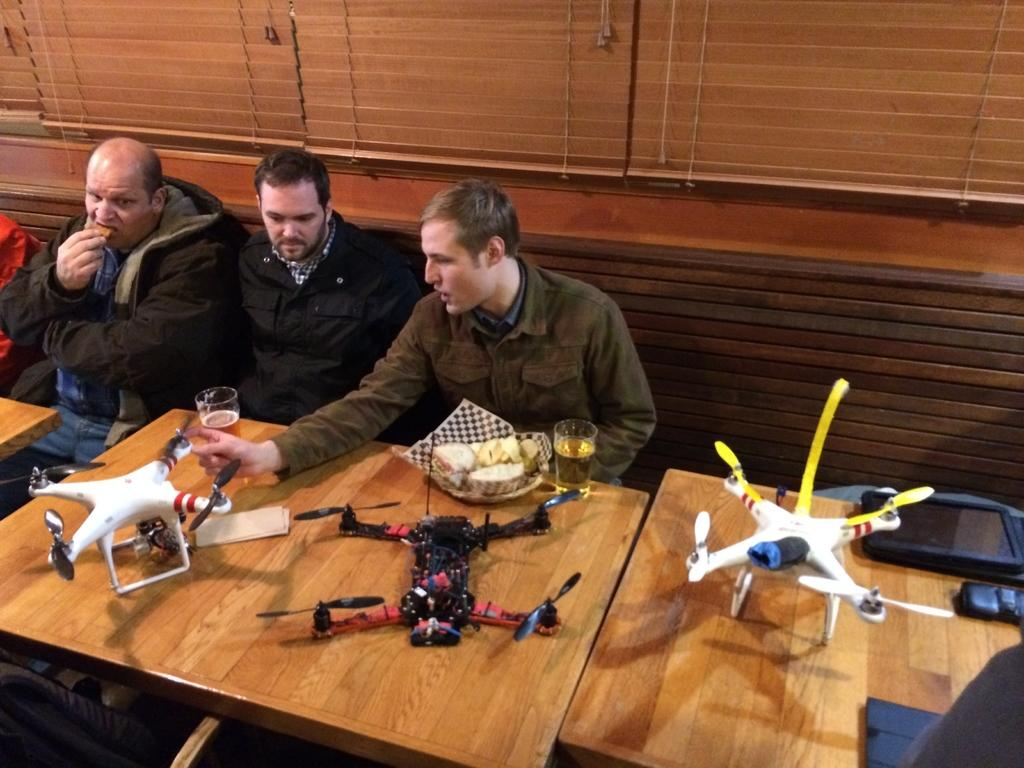What type of furniture can be seen in the image? There are tables in the image. What objects are on the tables? Drones and glasses are on the tables. Are there any other items on the tables? Yes, there are other items on the tables. What are the men in the image doing? There are three men sitting on a bench in the image. What can be seen in the background of the image? There are curtains of windows in the background of the image. Is there a parcel being delivered to the men on the bench in the image? There is no mention of a parcel or delivery in the image. Is this a birthday celebration, as indicated by the presence of the drones and glasses? There is no indication in the image that this is a birthday celebration. 